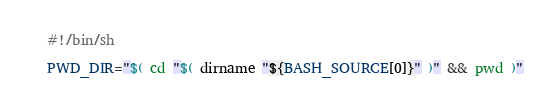Convert code to text. <code><loc_0><loc_0><loc_500><loc_500><_Bash_>#!/bin/sh

PWD_DIR="$( cd "$( dirname "${BASH_SOURCE[0]}" )" && pwd )"
</code> 